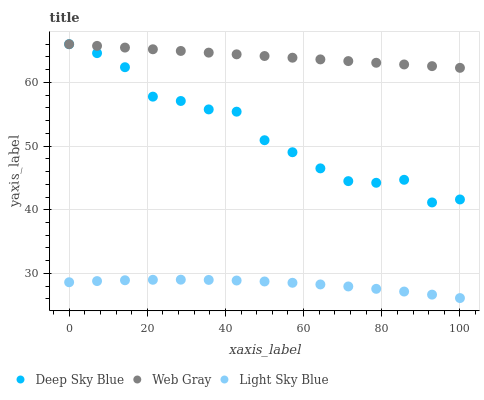Does Light Sky Blue have the minimum area under the curve?
Answer yes or no. Yes. Does Web Gray have the maximum area under the curve?
Answer yes or no. Yes. Does Deep Sky Blue have the minimum area under the curve?
Answer yes or no. No. Does Deep Sky Blue have the maximum area under the curve?
Answer yes or no. No. Is Web Gray the smoothest?
Answer yes or no. Yes. Is Deep Sky Blue the roughest?
Answer yes or no. Yes. Is Light Sky Blue the smoothest?
Answer yes or no. No. Is Light Sky Blue the roughest?
Answer yes or no. No. Does Light Sky Blue have the lowest value?
Answer yes or no. Yes. Does Deep Sky Blue have the lowest value?
Answer yes or no. No. Does Deep Sky Blue have the highest value?
Answer yes or no. Yes. Does Light Sky Blue have the highest value?
Answer yes or no. No. Is Light Sky Blue less than Deep Sky Blue?
Answer yes or no. Yes. Is Web Gray greater than Light Sky Blue?
Answer yes or no. Yes. Does Web Gray intersect Deep Sky Blue?
Answer yes or no. Yes. Is Web Gray less than Deep Sky Blue?
Answer yes or no. No. Is Web Gray greater than Deep Sky Blue?
Answer yes or no. No. Does Light Sky Blue intersect Deep Sky Blue?
Answer yes or no. No. 